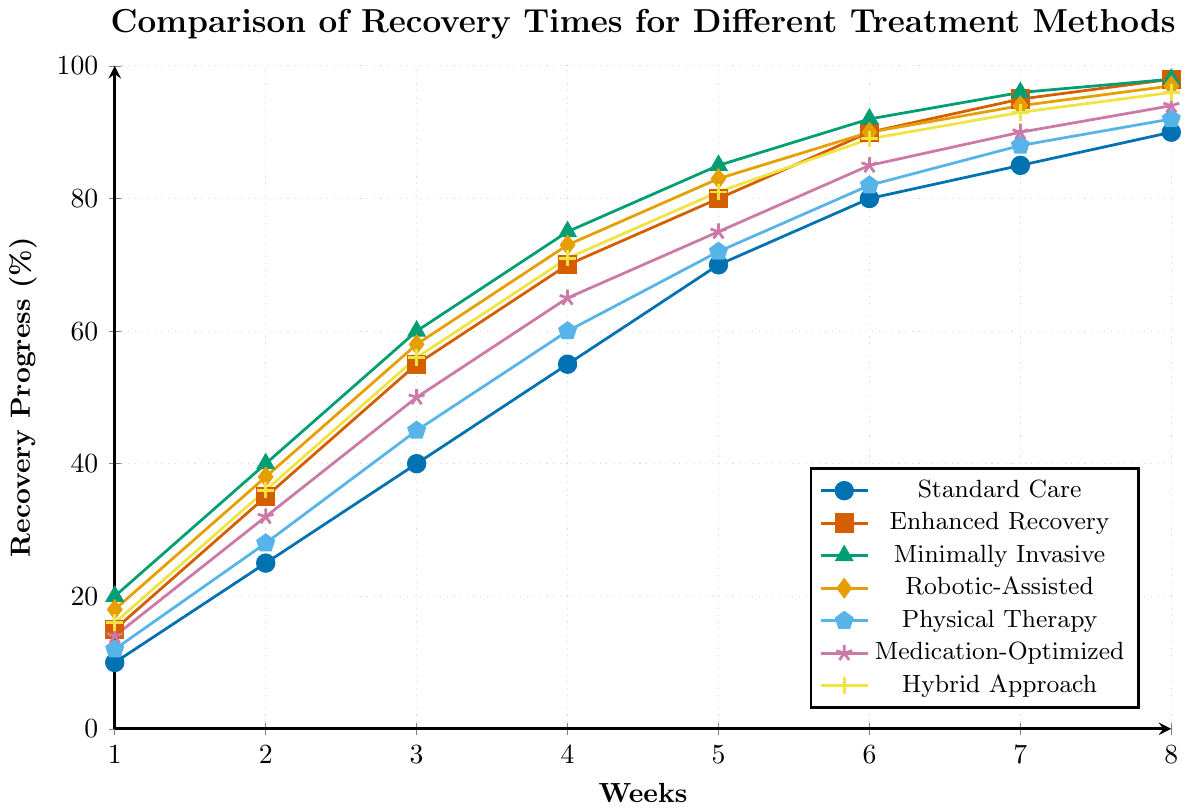Which treatment method shows the fastest recovery in Week 3? Identify the recovery percentages for Week 3 across all methods: Standard Care (40%), Enhanced Recovery (55%), Minimally Invasive Surgery (60%), Robotic-Assisted Surgery (58%), Physical Therapy Focused (45%), Medication-Optimized (50%), and Hybrid Approach (56%). The highest value, 60%, is achieved by Minimally Invasive Surgery.
Answer: Minimally Invasive Surgery Between Week 4 and Week 6, which treatment method shows the greatest improvement in recovery progress? Calculate the differences between Week 4 and Week 6 recovery percentages for each method: Standard Care (80-55 = 25), Enhanced Recovery (90-70 = 20), Minimally Invasive Surgery (92-75 = 17), Robotic-Assisted Surgery (90-73 = 17), Physical Therapy Focused (82-60 = 22), Medication-Optimized (85-65 = 20), Hybrid Approach (89-71 = 18). Standard Care shows the greatest improvement (25%).
Answer: Standard Care What is the average recovery progress for the Hybrid Approach over all weeks? Sum the recovery percentages for the Hybrid Approach across all weeks (16+36+56+71+81+89+93+96) = 538, and divide by the number of weeks (8). The average is 538/8 = 67.25%.
Answer: 67.25% Which treatment method reaches 90% recovery the earliest? Identify the respective weeks when each method reaches or surpasses 90% recovery: Standard Care (Week 6), Enhanced Recovery (Week 6), Minimally Invasive Surgery (Week 6), Robotic-Assisted Surgery (Week 6), Physical Therapy Focused (Week 8), Medication-Optimized (Week 6), and Hybrid Approach (Week 7). All but Physical Therapy Focused and Hybrid Approach reach 90% by Week 6, making them the earliest.
Answer: Standard Care, Enhanced Recovery, Minimally Invasive Surgery, Robotic-Assisted Surgery, Medication-Optimized (all in Week 6) How much faster does Enhanced Recovery Protocol reach 70% recovery compared to Standard Care? Identify the week each method reaches 70% recovery: Enhanced Recovery Protocol (Week 4), Standard Care (Week 5). Calculate the difference in weeks: Week 5 - Week 4 = 1 week faster.
Answer: 1 week In Week 8, how much higher is the recovery progress of Minimally Invasive Surgery compared to Physical Therapy Focused? Evaluate the recovery percentages in Week 8 for both methods: Minimally Invasive Surgery (98%), Physical Therapy Focused (92%). Calculate the difference: 98% - 92% = 6%.
Answer: 6% Which treatment method has the most consistent recovery rate (least variation) over the 8 weeks? Assess the variation in recovery percentages for each treatment by considering how steep or gradual their lines are. Enhanced Recovery Protocol and Minimally Invasive Surgery have smooth, consistent increases. Enhanced Recovery Protocol has a nearly straight line with less variation overall.
Answer: Enhanced Recovery Protocol 